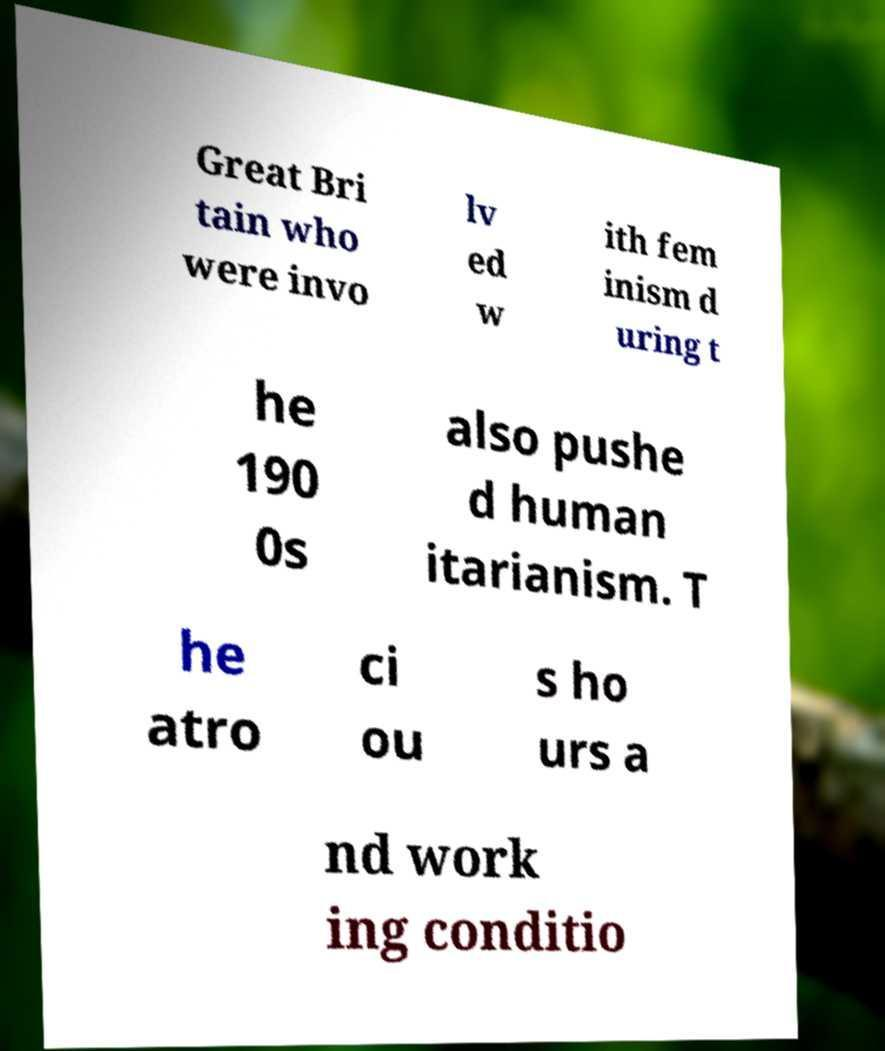What messages or text are displayed in this image? I need them in a readable, typed format. Great Bri tain who were invo lv ed w ith fem inism d uring t he 190 0s also pushe d human itarianism. T he atro ci ou s ho urs a nd work ing conditio 